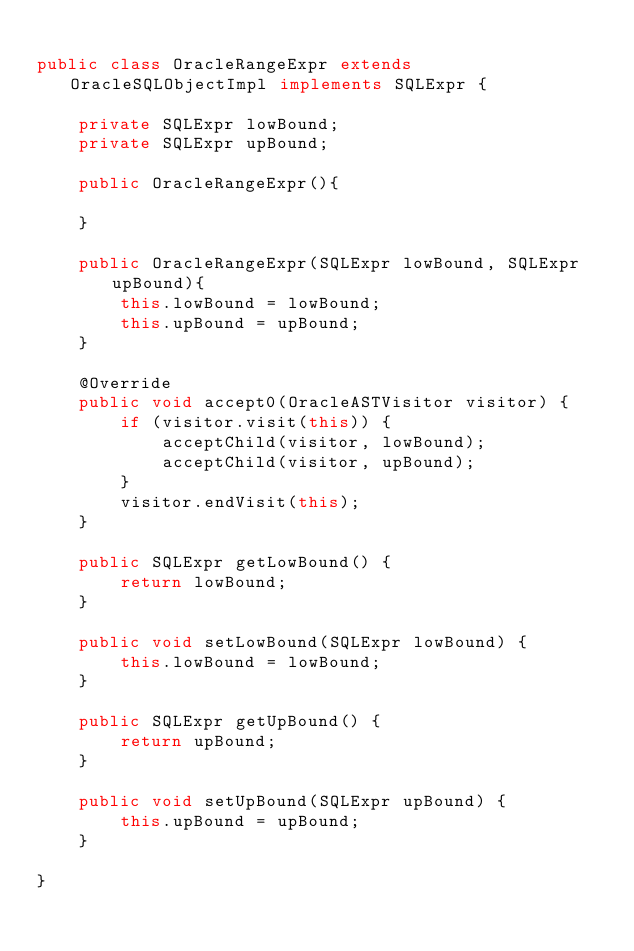Convert code to text. <code><loc_0><loc_0><loc_500><loc_500><_Java_>
public class OracleRangeExpr extends OracleSQLObjectImpl implements SQLExpr {

    private SQLExpr lowBound;
    private SQLExpr upBound;

    public OracleRangeExpr(){

    }

    public OracleRangeExpr(SQLExpr lowBound, SQLExpr upBound){
        this.lowBound = lowBound;
        this.upBound = upBound;
    }

    @Override
    public void accept0(OracleASTVisitor visitor) {
        if (visitor.visit(this)) {
            acceptChild(visitor, lowBound);
            acceptChild(visitor, upBound);
        }
        visitor.endVisit(this);
    }

    public SQLExpr getLowBound() {
        return lowBound;
    }

    public void setLowBound(SQLExpr lowBound) {
        this.lowBound = lowBound;
    }

    public SQLExpr getUpBound() {
        return upBound;
    }

    public void setUpBound(SQLExpr upBound) {
        this.upBound = upBound;
    }

}
</code> 